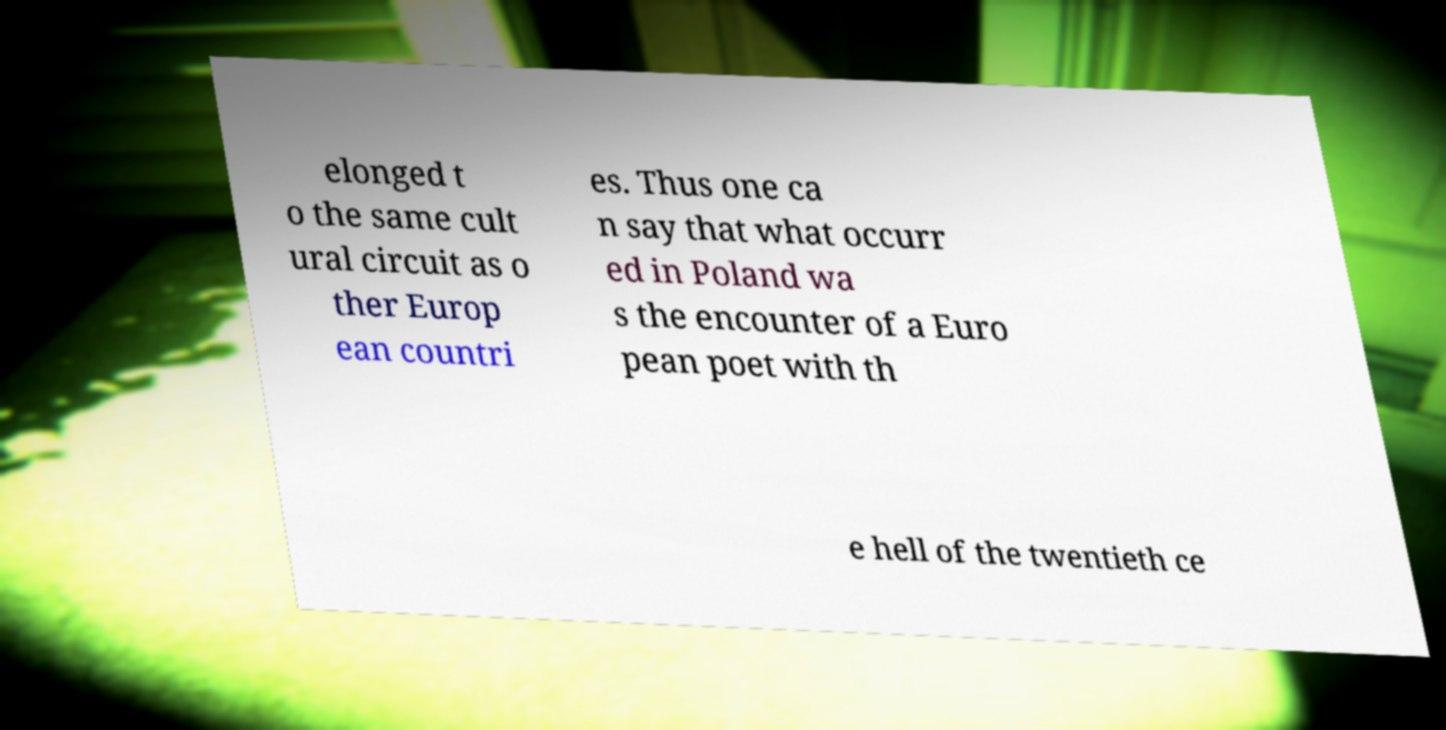Can you accurately transcribe the text from the provided image for me? elonged t o the same cult ural circuit as o ther Europ ean countri es. Thus one ca n say that what occurr ed in Poland wa s the encounter of a Euro pean poet with th e hell of the twentieth ce 